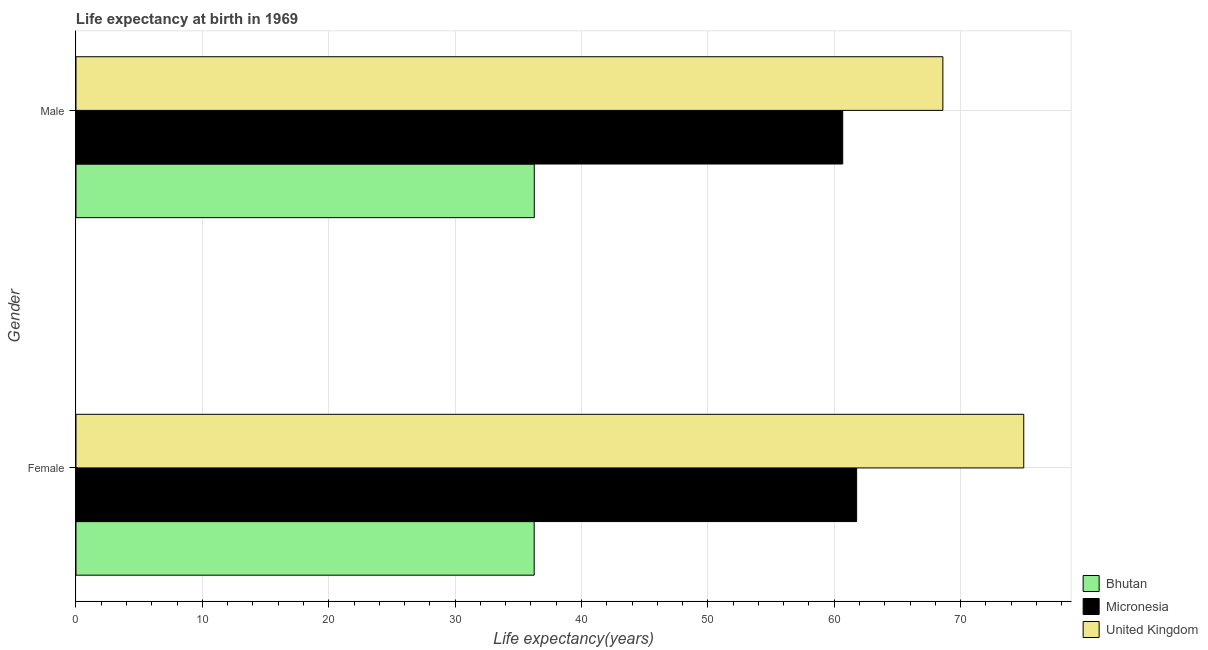How many different coloured bars are there?
Provide a succinct answer. 3. Are the number of bars per tick equal to the number of legend labels?
Your response must be concise. Yes. Are the number of bars on each tick of the Y-axis equal?
Your response must be concise. Yes. How many bars are there on the 1st tick from the top?
Provide a succinct answer. 3. What is the life expectancy(male) in United Kingdom?
Provide a short and direct response. 68.6. Across all countries, what is the minimum life expectancy(male)?
Your answer should be very brief. 36.27. In which country was the life expectancy(female) maximum?
Offer a very short reply. United Kingdom. In which country was the life expectancy(male) minimum?
Your answer should be very brief. Bhutan. What is the total life expectancy(male) in the graph?
Offer a very short reply. 165.54. What is the difference between the life expectancy(male) in United Kingdom and that in Bhutan?
Your response must be concise. 32.33. What is the difference between the life expectancy(male) in United Kingdom and the life expectancy(female) in Micronesia?
Keep it short and to the point. 6.82. What is the average life expectancy(female) per country?
Your response must be concise. 57.68. What is the difference between the life expectancy(male) and life expectancy(female) in United Kingdom?
Provide a short and direct response. -6.4. What is the ratio of the life expectancy(male) in United Kingdom to that in Micronesia?
Keep it short and to the point. 1.13. In how many countries, is the life expectancy(male) greater than the average life expectancy(male) taken over all countries?
Your response must be concise. 2. What does the 2nd bar from the top in Female represents?
Ensure brevity in your answer.  Micronesia. What does the 1st bar from the bottom in Male represents?
Ensure brevity in your answer.  Bhutan. How many countries are there in the graph?
Give a very brief answer. 3. What is the difference between two consecutive major ticks on the X-axis?
Your response must be concise. 10. Are the values on the major ticks of X-axis written in scientific E-notation?
Your answer should be very brief. No. Where does the legend appear in the graph?
Your answer should be compact. Bottom right. What is the title of the graph?
Your answer should be compact. Life expectancy at birth in 1969. Does "Montenegro" appear as one of the legend labels in the graph?
Ensure brevity in your answer.  No. What is the label or title of the X-axis?
Your answer should be compact. Life expectancy(years). What is the Life expectancy(years) in Bhutan in Female?
Your response must be concise. 36.26. What is the Life expectancy(years) in Micronesia in Female?
Ensure brevity in your answer.  61.77. What is the Life expectancy(years) in United Kingdom in Female?
Your answer should be very brief. 75. What is the Life expectancy(years) of Bhutan in Male?
Offer a very short reply. 36.27. What is the Life expectancy(years) of Micronesia in Male?
Your answer should be very brief. 60.67. What is the Life expectancy(years) in United Kingdom in Male?
Offer a terse response. 68.6. Across all Gender, what is the maximum Life expectancy(years) of Bhutan?
Give a very brief answer. 36.27. Across all Gender, what is the maximum Life expectancy(years) of Micronesia?
Keep it short and to the point. 61.77. Across all Gender, what is the maximum Life expectancy(years) of United Kingdom?
Your answer should be compact. 75. Across all Gender, what is the minimum Life expectancy(years) of Bhutan?
Keep it short and to the point. 36.26. Across all Gender, what is the minimum Life expectancy(years) of Micronesia?
Your response must be concise. 60.67. Across all Gender, what is the minimum Life expectancy(years) of United Kingdom?
Ensure brevity in your answer.  68.6. What is the total Life expectancy(years) in Bhutan in the graph?
Keep it short and to the point. 72.53. What is the total Life expectancy(years) in Micronesia in the graph?
Offer a terse response. 122.45. What is the total Life expectancy(years) in United Kingdom in the graph?
Your answer should be compact. 143.6. What is the difference between the Life expectancy(years) in Bhutan in Female and that in Male?
Provide a succinct answer. -0.01. What is the difference between the Life expectancy(years) of United Kingdom in Female and that in Male?
Give a very brief answer. 6.4. What is the difference between the Life expectancy(years) of Bhutan in Female and the Life expectancy(years) of Micronesia in Male?
Provide a succinct answer. -24.42. What is the difference between the Life expectancy(years) of Bhutan in Female and the Life expectancy(years) of United Kingdom in Male?
Your answer should be very brief. -32.34. What is the difference between the Life expectancy(years) in Micronesia in Female and the Life expectancy(years) in United Kingdom in Male?
Provide a short and direct response. -6.83. What is the average Life expectancy(years) of Bhutan per Gender?
Provide a succinct answer. 36.26. What is the average Life expectancy(years) in Micronesia per Gender?
Make the answer very short. 61.23. What is the average Life expectancy(years) of United Kingdom per Gender?
Make the answer very short. 71.8. What is the difference between the Life expectancy(years) of Bhutan and Life expectancy(years) of Micronesia in Female?
Give a very brief answer. -25.52. What is the difference between the Life expectancy(years) in Bhutan and Life expectancy(years) in United Kingdom in Female?
Your response must be concise. -38.74. What is the difference between the Life expectancy(years) of Micronesia and Life expectancy(years) of United Kingdom in Female?
Provide a short and direct response. -13.22. What is the difference between the Life expectancy(years) in Bhutan and Life expectancy(years) in Micronesia in Male?
Ensure brevity in your answer.  -24.41. What is the difference between the Life expectancy(years) in Bhutan and Life expectancy(years) in United Kingdom in Male?
Keep it short and to the point. -32.33. What is the difference between the Life expectancy(years) in Micronesia and Life expectancy(years) in United Kingdom in Male?
Offer a terse response. -7.92. What is the ratio of the Life expectancy(years) of Bhutan in Female to that in Male?
Provide a short and direct response. 1. What is the ratio of the Life expectancy(years) in Micronesia in Female to that in Male?
Provide a succinct answer. 1.02. What is the ratio of the Life expectancy(years) in United Kingdom in Female to that in Male?
Offer a very short reply. 1.09. What is the difference between the highest and the second highest Life expectancy(years) of Bhutan?
Your response must be concise. 0.01. What is the difference between the highest and the lowest Life expectancy(years) in Bhutan?
Your answer should be very brief. 0.01. What is the difference between the highest and the lowest Life expectancy(years) in Micronesia?
Keep it short and to the point. 1.1. What is the difference between the highest and the lowest Life expectancy(years) of United Kingdom?
Offer a terse response. 6.4. 